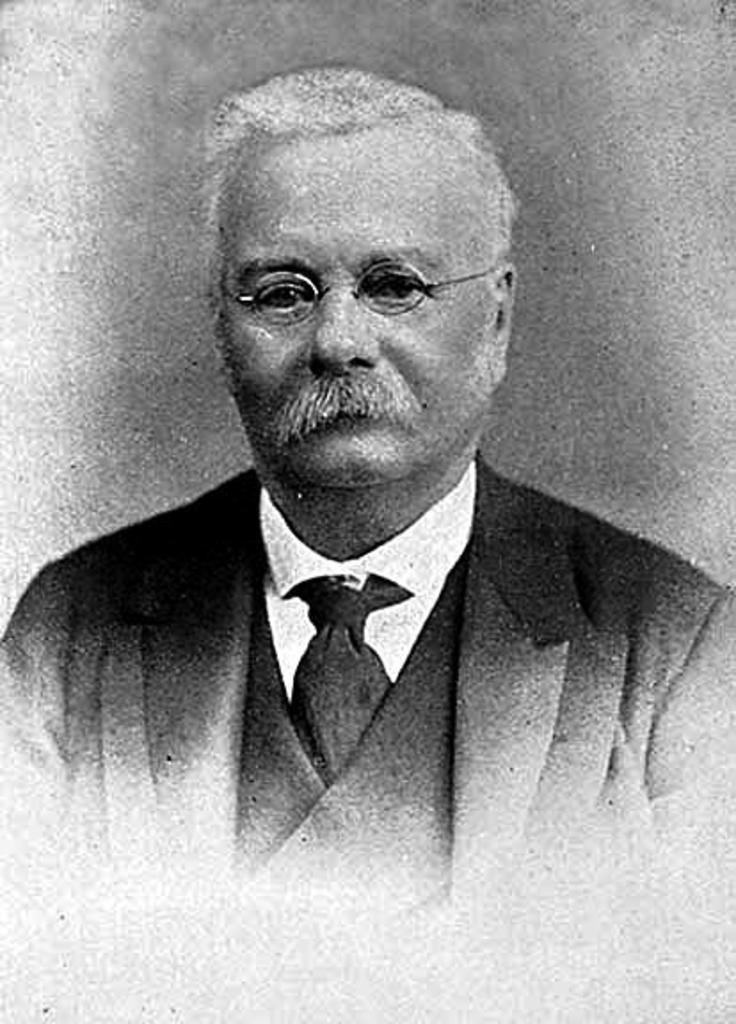What is the color scheme of the image? The image is black and white. Can you describe the main subject in the image? There is a person in the image. What accessory is the person wearing in the image? The person is wearing spectacles. What type of rhythm can be heard in the image? There is no sound or rhythm present in the image, as it is a still, black and white photograph. 